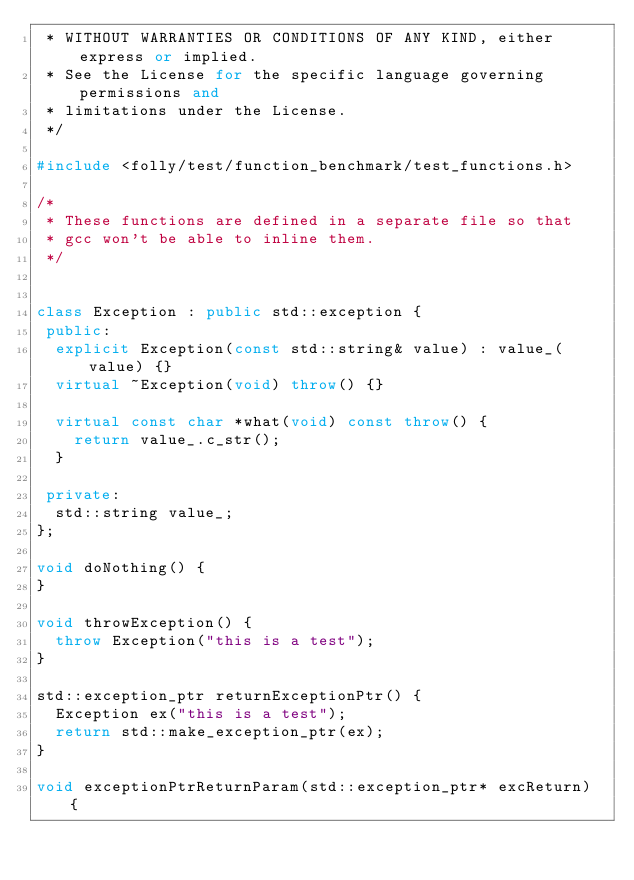<code> <loc_0><loc_0><loc_500><loc_500><_C++_> * WITHOUT WARRANTIES OR CONDITIONS OF ANY KIND, either express or implied.
 * See the License for the specific language governing permissions and
 * limitations under the License.
 */

#include <folly/test/function_benchmark/test_functions.h>

/*
 * These functions are defined in a separate file so that
 * gcc won't be able to inline them.
 */


class Exception : public std::exception {
 public:
  explicit Exception(const std::string& value) : value_(value) {}
  virtual ~Exception(void) throw() {}

  virtual const char *what(void) const throw() {
    return value_.c_str();
  }

 private:
  std::string value_;
};

void doNothing() {
}

void throwException() {
  throw Exception("this is a test");
}

std::exception_ptr returnExceptionPtr() {
  Exception ex("this is a test");
  return std::make_exception_ptr(ex);
}

void exceptionPtrReturnParam(std::exception_ptr* excReturn) {</code> 